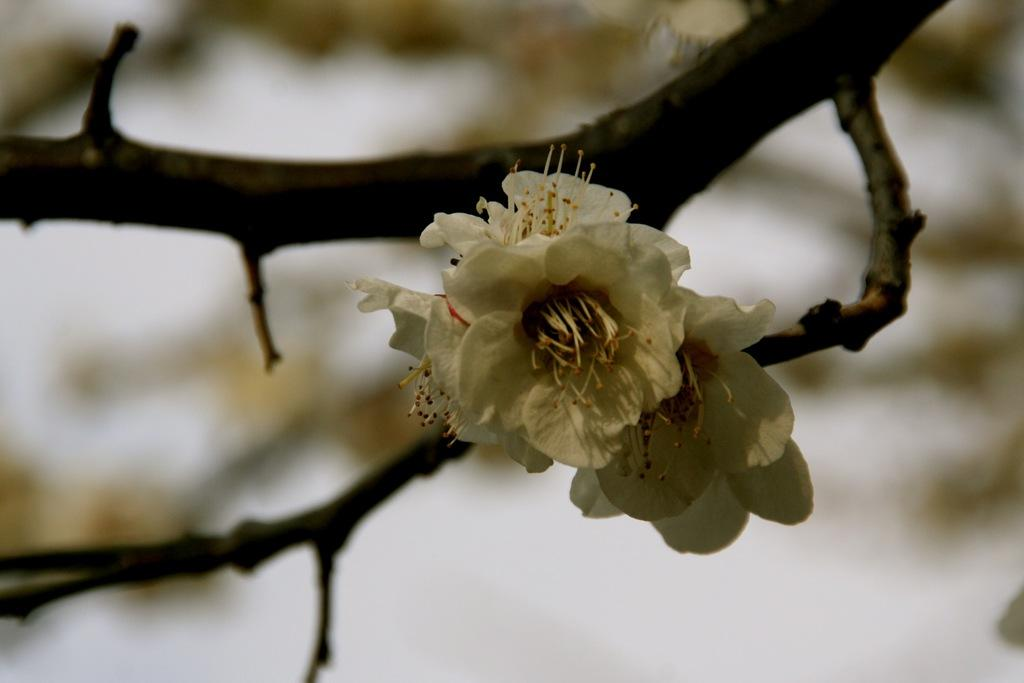What type of plants are in the image? There are flowers in the image. Can you describe the structure of the flowers? The flowers have stems. What type of clocks can be seen hanging from the stems of the flowers in the image? There are no clocks present in the image, and clocks are not typically associated with flowers. 